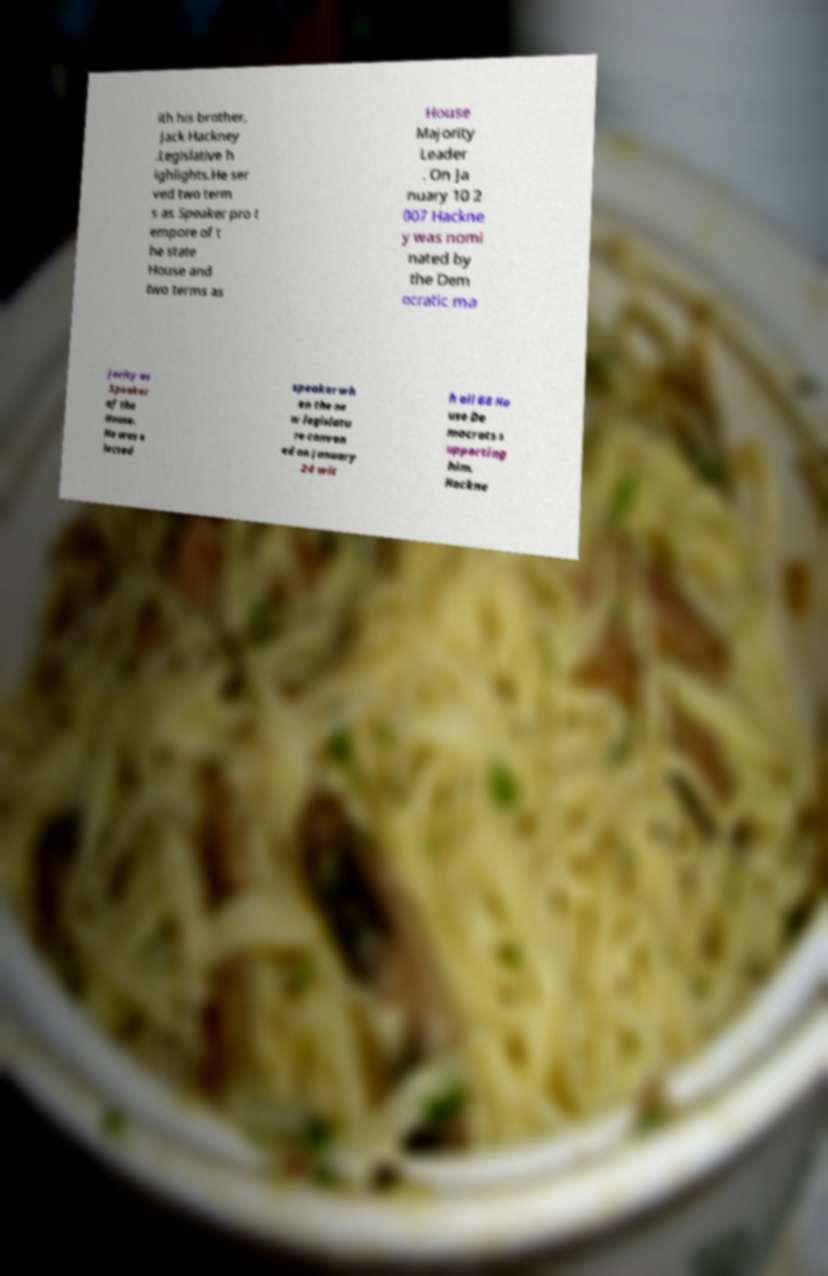I need the written content from this picture converted into text. Can you do that? ith his brother, Jack Hackney .Legislative h ighlights.He ser ved two term s as Speaker pro t empore of t he state House and two terms as House Majority Leader . On Ja nuary 10 2 007 Hackne y was nomi nated by the Dem ocratic ma jority as Speaker of the House. He was e lected speaker wh en the ne w legislatu re conven ed on January 24 wit h all 68 Ho use De mocrats s upporting him. Hackne 